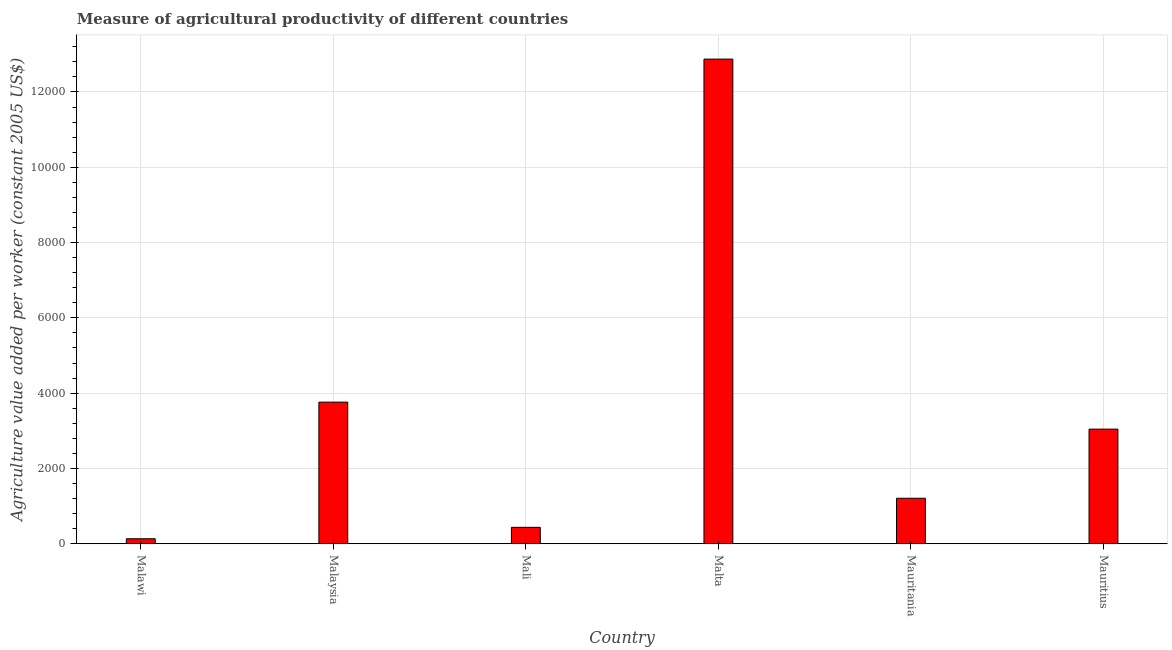Does the graph contain any zero values?
Offer a very short reply. No. Does the graph contain grids?
Your answer should be very brief. Yes. What is the title of the graph?
Give a very brief answer. Measure of agricultural productivity of different countries. What is the label or title of the X-axis?
Make the answer very short. Country. What is the label or title of the Y-axis?
Offer a terse response. Agriculture value added per worker (constant 2005 US$). What is the agriculture value added per worker in Malaysia?
Ensure brevity in your answer.  3761.13. Across all countries, what is the maximum agriculture value added per worker?
Ensure brevity in your answer.  1.29e+04. Across all countries, what is the minimum agriculture value added per worker?
Your response must be concise. 132.45. In which country was the agriculture value added per worker maximum?
Offer a terse response. Malta. In which country was the agriculture value added per worker minimum?
Provide a short and direct response. Malawi. What is the sum of the agriculture value added per worker?
Provide a short and direct response. 2.15e+04. What is the difference between the agriculture value added per worker in Malawi and Mauritius?
Provide a short and direct response. -2911.79. What is the average agriculture value added per worker per country?
Offer a very short reply. 3575.74. What is the median agriculture value added per worker?
Provide a short and direct response. 2126.18. What is the ratio of the agriculture value added per worker in Mauritania to that in Mauritius?
Your answer should be compact. 0.4. What is the difference between the highest and the second highest agriculture value added per worker?
Provide a succinct answer. 9111.35. Is the sum of the agriculture value added per worker in Mauritania and Mauritius greater than the maximum agriculture value added per worker across all countries?
Your response must be concise. No. What is the difference between the highest and the lowest agriculture value added per worker?
Keep it short and to the point. 1.27e+04. Are all the bars in the graph horizontal?
Give a very brief answer. No. What is the difference between two consecutive major ticks on the Y-axis?
Offer a very short reply. 2000. Are the values on the major ticks of Y-axis written in scientific E-notation?
Offer a very short reply. No. What is the Agriculture value added per worker (constant 2005 US$) in Malawi?
Provide a short and direct response. 132.45. What is the Agriculture value added per worker (constant 2005 US$) of Malaysia?
Ensure brevity in your answer.  3761.13. What is the Agriculture value added per worker (constant 2005 US$) of Mali?
Make the answer very short. 435.99. What is the Agriculture value added per worker (constant 2005 US$) of Malta?
Provide a short and direct response. 1.29e+04. What is the Agriculture value added per worker (constant 2005 US$) of Mauritania?
Your response must be concise. 1208.11. What is the Agriculture value added per worker (constant 2005 US$) in Mauritius?
Give a very brief answer. 3044.25. What is the difference between the Agriculture value added per worker (constant 2005 US$) in Malawi and Malaysia?
Your response must be concise. -3628.68. What is the difference between the Agriculture value added per worker (constant 2005 US$) in Malawi and Mali?
Give a very brief answer. -303.53. What is the difference between the Agriculture value added per worker (constant 2005 US$) in Malawi and Malta?
Keep it short and to the point. -1.27e+04. What is the difference between the Agriculture value added per worker (constant 2005 US$) in Malawi and Mauritania?
Offer a terse response. -1075.66. What is the difference between the Agriculture value added per worker (constant 2005 US$) in Malawi and Mauritius?
Provide a succinct answer. -2911.79. What is the difference between the Agriculture value added per worker (constant 2005 US$) in Malaysia and Mali?
Offer a terse response. 3325.14. What is the difference between the Agriculture value added per worker (constant 2005 US$) in Malaysia and Malta?
Give a very brief answer. -9111.35. What is the difference between the Agriculture value added per worker (constant 2005 US$) in Malaysia and Mauritania?
Make the answer very short. 2553.02. What is the difference between the Agriculture value added per worker (constant 2005 US$) in Malaysia and Mauritius?
Your answer should be compact. 716.88. What is the difference between the Agriculture value added per worker (constant 2005 US$) in Mali and Malta?
Offer a terse response. -1.24e+04. What is the difference between the Agriculture value added per worker (constant 2005 US$) in Mali and Mauritania?
Provide a succinct answer. -772.12. What is the difference between the Agriculture value added per worker (constant 2005 US$) in Mali and Mauritius?
Offer a very short reply. -2608.26. What is the difference between the Agriculture value added per worker (constant 2005 US$) in Malta and Mauritania?
Make the answer very short. 1.17e+04. What is the difference between the Agriculture value added per worker (constant 2005 US$) in Malta and Mauritius?
Provide a short and direct response. 9828.23. What is the difference between the Agriculture value added per worker (constant 2005 US$) in Mauritania and Mauritius?
Ensure brevity in your answer.  -1836.14. What is the ratio of the Agriculture value added per worker (constant 2005 US$) in Malawi to that in Malaysia?
Keep it short and to the point. 0.04. What is the ratio of the Agriculture value added per worker (constant 2005 US$) in Malawi to that in Mali?
Ensure brevity in your answer.  0.3. What is the ratio of the Agriculture value added per worker (constant 2005 US$) in Malawi to that in Mauritania?
Provide a short and direct response. 0.11. What is the ratio of the Agriculture value added per worker (constant 2005 US$) in Malawi to that in Mauritius?
Offer a very short reply. 0.04. What is the ratio of the Agriculture value added per worker (constant 2005 US$) in Malaysia to that in Mali?
Your answer should be compact. 8.63. What is the ratio of the Agriculture value added per worker (constant 2005 US$) in Malaysia to that in Malta?
Offer a very short reply. 0.29. What is the ratio of the Agriculture value added per worker (constant 2005 US$) in Malaysia to that in Mauritania?
Offer a terse response. 3.11. What is the ratio of the Agriculture value added per worker (constant 2005 US$) in Malaysia to that in Mauritius?
Provide a succinct answer. 1.24. What is the ratio of the Agriculture value added per worker (constant 2005 US$) in Mali to that in Malta?
Provide a succinct answer. 0.03. What is the ratio of the Agriculture value added per worker (constant 2005 US$) in Mali to that in Mauritania?
Give a very brief answer. 0.36. What is the ratio of the Agriculture value added per worker (constant 2005 US$) in Mali to that in Mauritius?
Give a very brief answer. 0.14. What is the ratio of the Agriculture value added per worker (constant 2005 US$) in Malta to that in Mauritania?
Ensure brevity in your answer.  10.65. What is the ratio of the Agriculture value added per worker (constant 2005 US$) in Malta to that in Mauritius?
Give a very brief answer. 4.23. What is the ratio of the Agriculture value added per worker (constant 2005 US$) in Mauritania to that in Mauritius?
Offer a terse response. 0.4. 